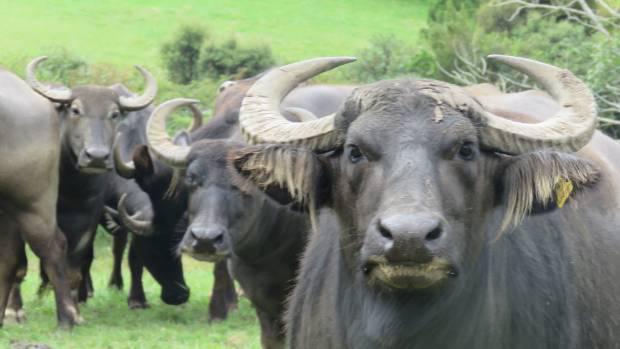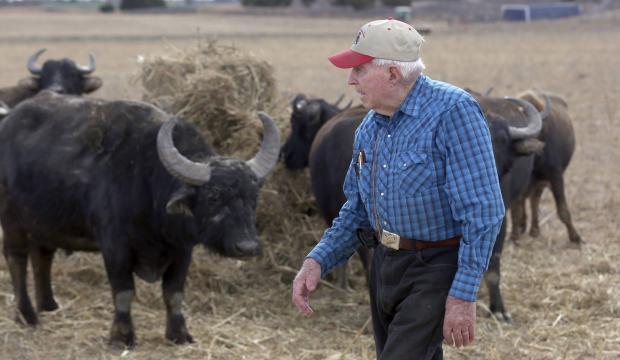The first image is the image on the left, the second image is the image on the right. For the images shown, is this caption "Each image shows a group of cattle-type animals walking down a path, and the right image shows a man holding a stick walking behind some of them." true? Answer yes or no. No. The first image is the image on the left, the second image is the image on the right. For the images shown, is this caption "There is a man standing with some cows in the image on the right." true? Answer yes or no. Yes. 